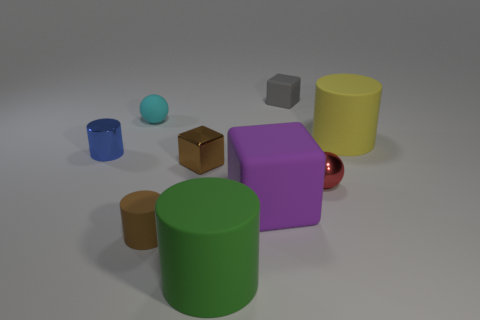There is a brown thing that is the same shape as the green rubber thing; what is it made of?
Offer a very short reply. Rubber. There is a cube that is on the right side of the big matte cube; what number of small red objects are behind it?
Make the answer very short. 0. Are there any other things that have the same material as the big yellow thing?
Make the answer very short. Yes. There is a cyan thing behind the large rubber thing that is behind the blue object behind the tiny matte cylinder; what is it made of?
Offer a terse response. Rubber. There is a cylinder that is behind the small brown cylinder and on the right side of the brown rubber object; what material is it made of?
Offer a terse response. Rubber. How many red things have the same shape as the cyan rubber thing?
Give a very brief answer. 1. There is a matte cube that is in front of the ball behind the big yellow matte object; what is its size?
Provide a succinct answer. Large. There is a small metallic thing that is in front of the small brown shiny cube; is its color the same as the big rubber cylinder that is on the left side of the large yellow matte cylinder?
Offer a terse response. No. There is a ball in front of the metallic cylinder that is to the left of the green matte cylinder; what number of tiny cyan objects are right of it?
Offer a very short reply. 0. What number of tiny rubber objects are both behind the red sphere and in front of the gray object?
Keep it short and to the point. 1. 